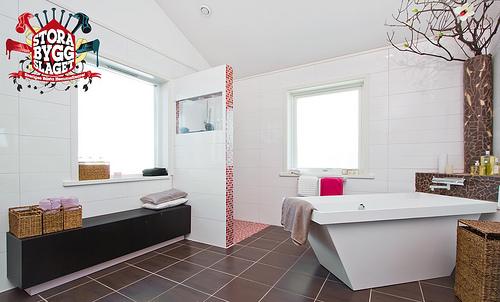What room is this?
Keep it brief. Bathroom. What is the floor made of?
Short answer required. Tile. What color are the walls?
Quick response, please. White. 